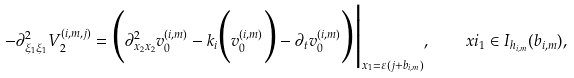<formula> <loc_0><loc_0><loc_500><loc_500>- \partial ^ { 2 } _ { \xi _ { 1 } \xi _ { 1 } } V ^ { ( i , m , j ) } _ { 2 } = \Big ( \partial ^ { 2 } _ { x _ { 2 } x _ { 2 } } v ^ { ( i , m ) } _ { 0 } - k _ { i } \Big ( v ^ { ( i , m ) } _ { 0 } \Big ) - \partial _ { t } v ^ { ( i , m ) } _ { 0 } \Big ) \Big | _ { x _ { 1 } = \varepsilon ( j + b _ { i , m } ) } , \quad x i _ { 1 } \in I _ { h _ { i , m } } ( b _ { i , m } ) ,</formula> 